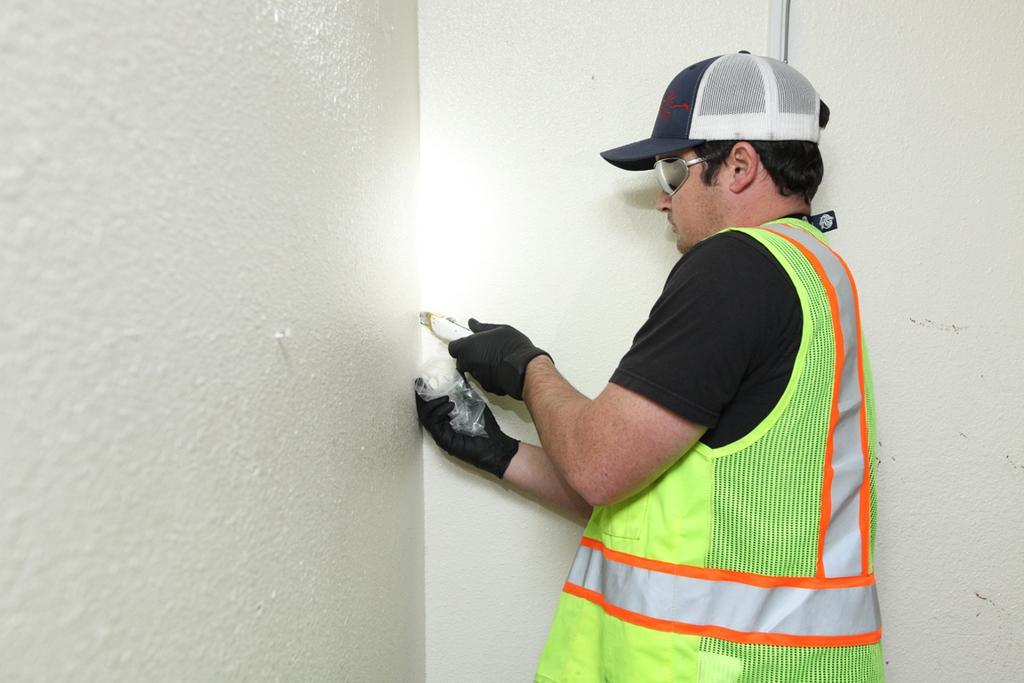In one or two sentences, can you explain what this image depicts? In this image I can see a man in the front and I can see he is wearing neon colour jacket, black gloves, shades, black t shirt and a cap. I can see he is holding a white colour thing and a plastic. On the left side and in the background I can see white colour walls. 